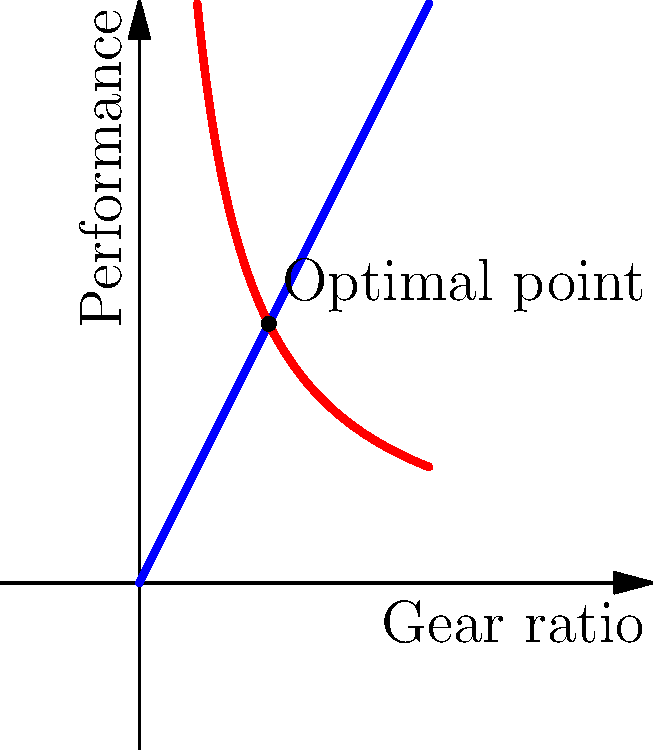In designing a wind-up toy for a new board game, you need to determine the optimal gear ratio to balance speed and torque. The graph shows the relationship between gear ratio, speed (blue line), and torque (red line). What is the approximate optimal gear ratio that maximizes both speed and torque? To find the optimal gear ratio, we need to follow these steps:

1. Understand the graph:
   - The blue line represents speed, which increases linearly with gear ratio.
   - The red line represents torque, which decreases inversely with gear ratio.

2. Identify the optimal point:
   - The optimal point is where speed and torque are balanced.
   - This occurs at the intersection of the two lines.

3. Find the intersection point:
   - The lines intersect where the speed and torque values are equal.
   - We can see this point is marked on the graph.

4. Read the gear ratio:
   - The x-coordinate of the intersection point gives us the optimal gear ratio.
   - From the graph, we can estimate this value to be approximately 2.2 to 2.3.

5. Interpret the result:
   - This gear ratio provides a balance between speed and torque for the wind-up toy.
   - It ensures the toy moves at a reasonable speed while having enough torque to overcome friction and obstacles in the game.

The optimal gear ratio is therefore approximately 2.2 to 2.3, which balances speed and torque for the wind-up toy in the board game.
Answer: Approximately 2.2 